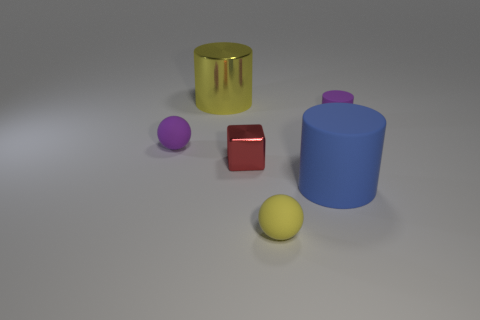Add 3 purple cylinders. How many objects exist? 9 Subtract all large blue rubber cylinders. How many cylinders are left? 2 Subtract 1 cubes. How many cubes are left? 0 Subtract all yellow cylinders. How many cylinders are left? 2 Add 1 green metallic spheres. How many green metallic spheres exist? 1 Subtract 0 blue cubes. How many objects are left? 6 Subtract all blocks. How many objects are left? 5 Subtract all cyan cubes. Subtract all red spheres. How many cubes are left? 1 Subtract all cyan cubes. How many yellow balls are left? 1 Subtract all purple rubber cylinders. Subtract all large cylinders. How many objects are left? 3 